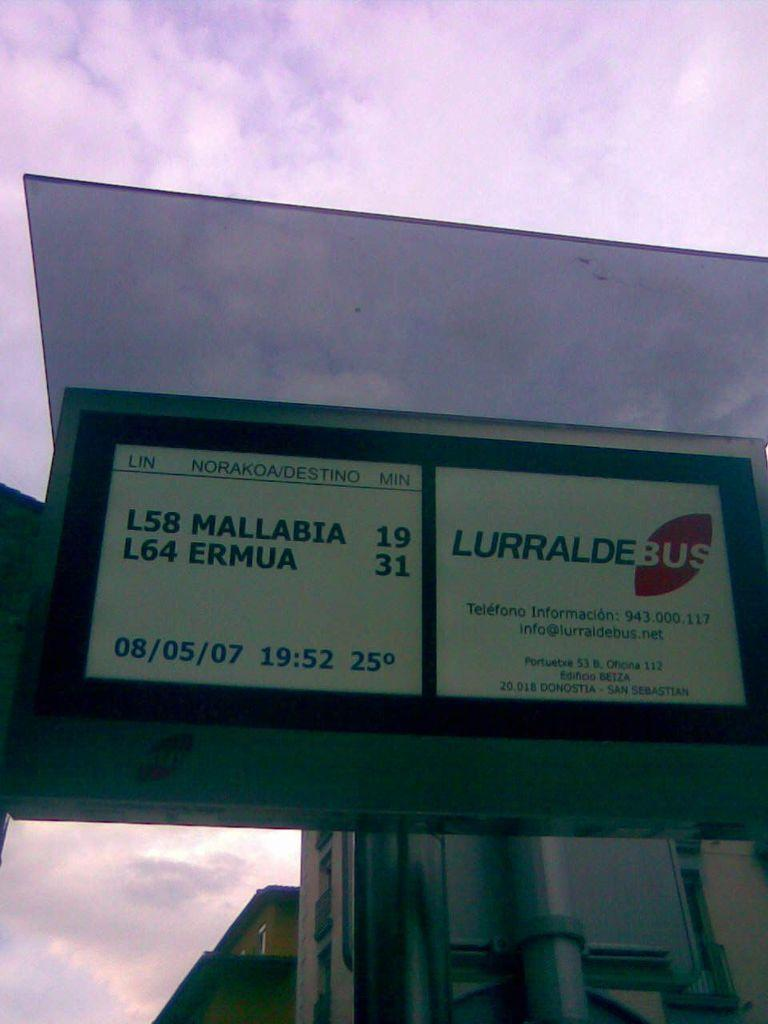Provide a one-sentence caption for the provided image. A bus sign for Lurralde bus on the date of 08/05/07. 